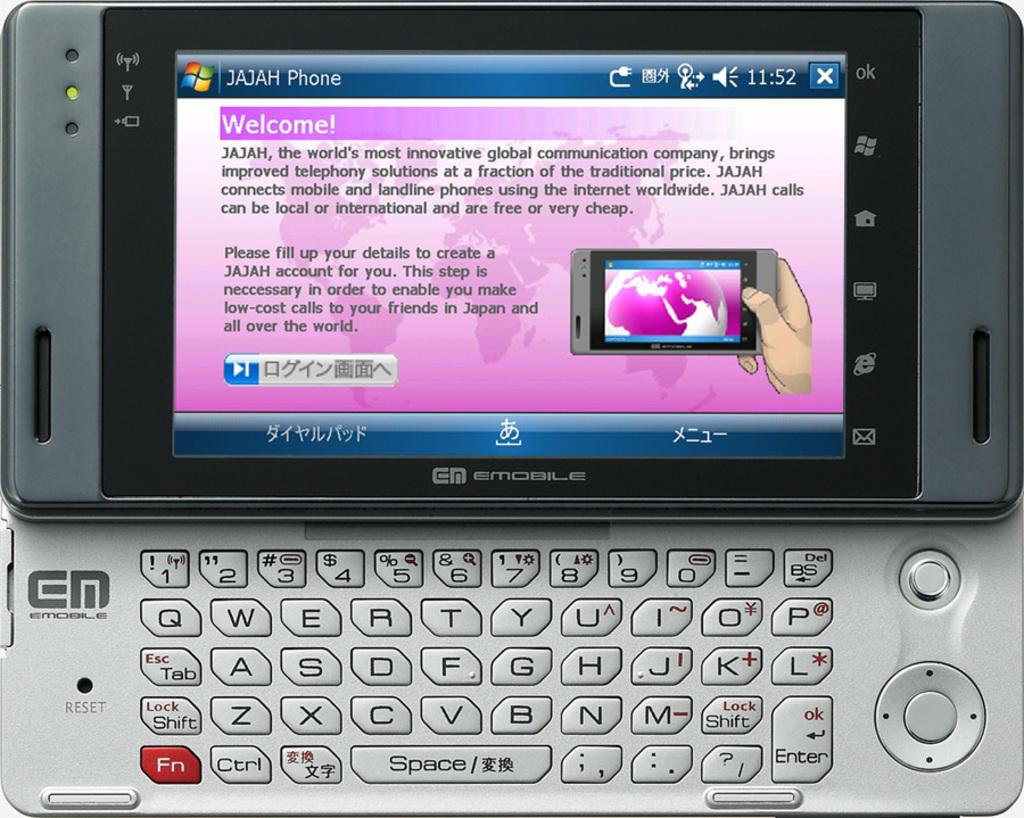What object is the main subject of the image? There is a mobile in the image. What features does the mobile have? The mobile has a keypad, a screen, icons, keys, text, and buttons. Is there any visual content on the mobile's screen? Yes, there is a picture visible on the mobile's screen. What type of rock is being played by the queen in the image? There is no queen or rock present in the image; it features a mobile with various features and a picture on its screen. 